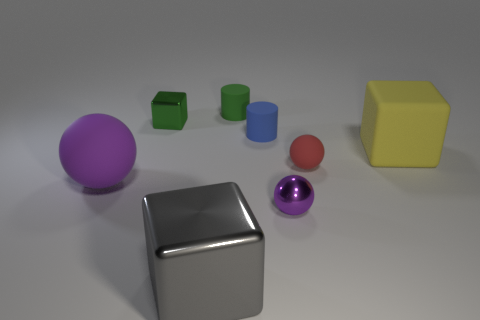There is a yellow object; what number of rubber objects are behind it?
Your answer should be compact. 2. Are there an equal number of yellow objects on the left side of the blue cylinder and small green objects on the left side of the large purple sphere?
Provide a succinct answer. Yes. The green object that is the same shape as the blue rubber thing is what size?
Keep it short and to the point. Small. What is the shape of the purple object right of the small block?
Keep it short and to the point. Sphere. Is the cylinder in front of the green metallic cube made of the same material as the big block in front of the big yellow rubber cube?
Your response must be concise. No. There is a yellow object; what shape is it?
Provide a short and direct response. Cube. Are there the same number of small cylinders on the left side of the large metallic thing and tiny blue objects?
Your response must be concise. No. The other sphere that is the same color as the large matte ball is what size?
Ensure brevity in your answer.  Small. Are there any yellow objects that have the same material as the tiny blue thing?
Offer a very short reply. Yes. Does the object to the right of the red rubber object have the same shape as the green matte object behind the red sphere?
Your answer should be compact. No. 